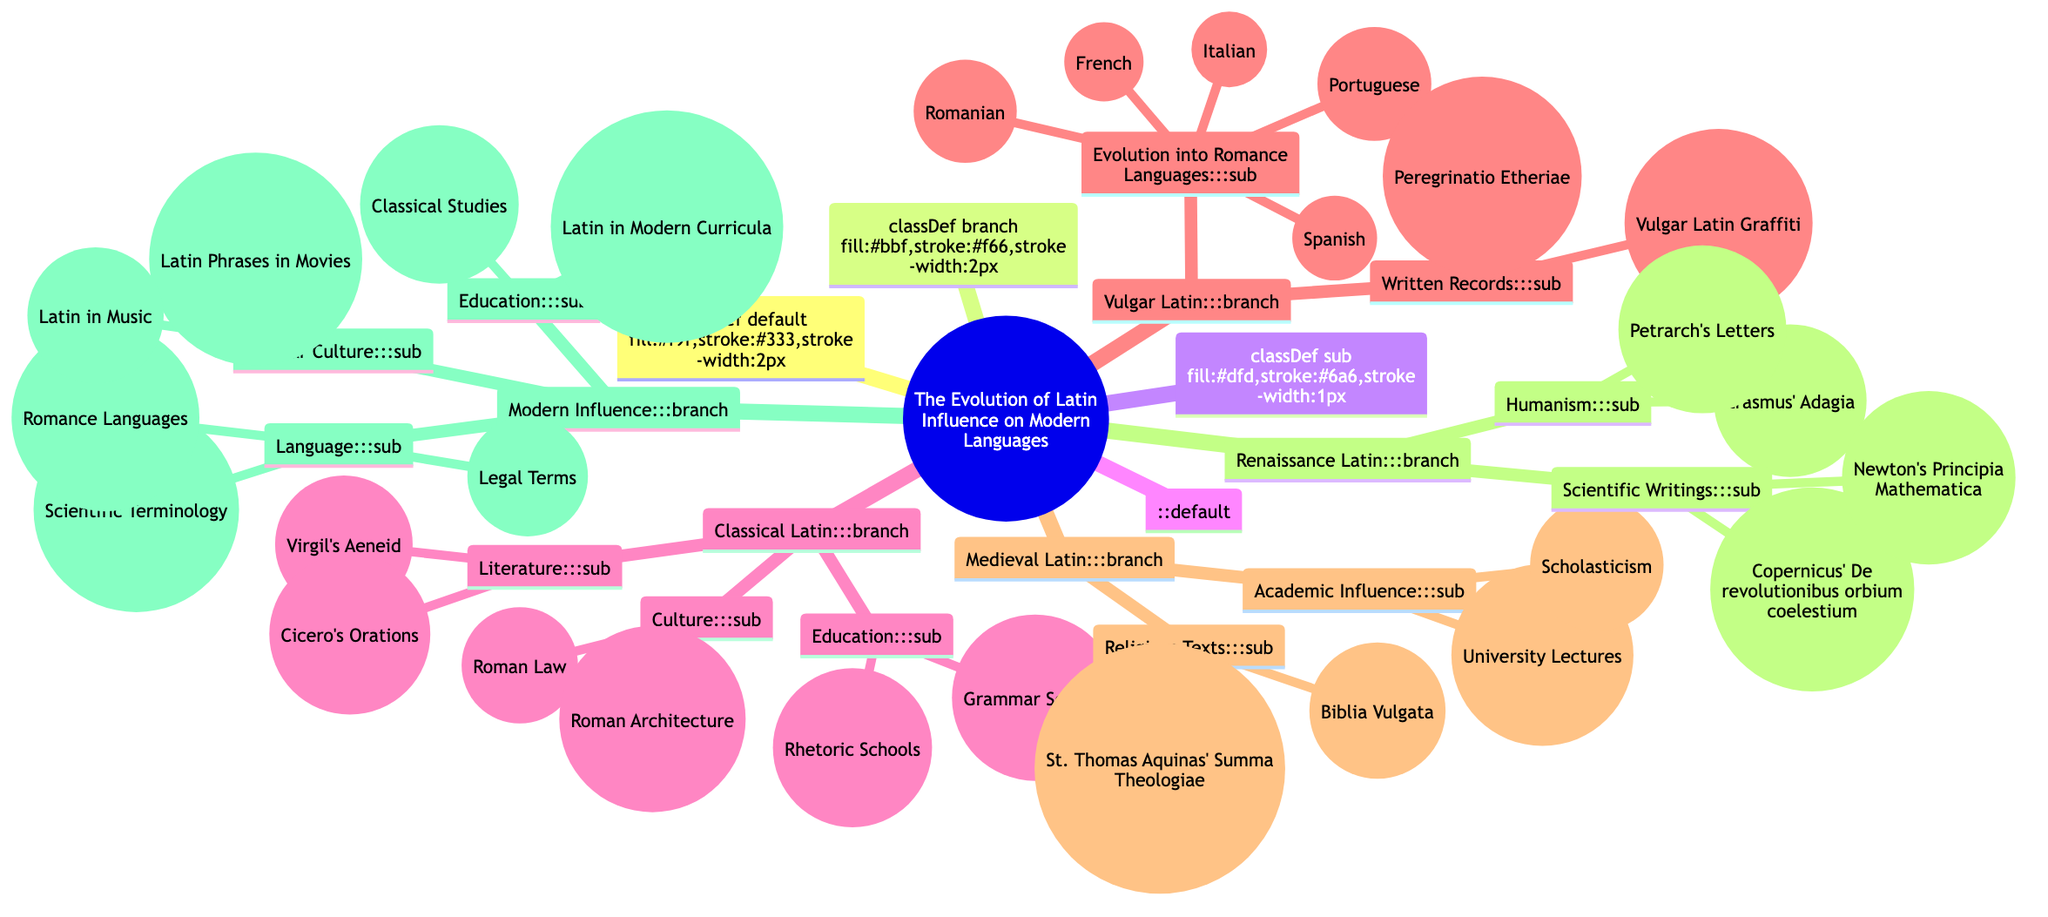What is the central theme of the mind map? The central theme is stated at the root of the mind map, which clearly identifies it as "The Evolution of Latin Influence on Modern Languages."
Answer: The Evolution of Latin Influence on Modern Languages How many main branches are in the mind map? By counting the main branches that extend from the central theme, we can identify five branches: Classical Latin, Vulgar Latin, Medieval Latin, Renaissance Latin, and Modern Influence.
Answer: 5 What literary work is mentioned under Classical Latin? Under the 'Literature' sub-branch of 'Classical Latin', "Virgil's Aeneid" is explicitly listed as an example.
Answer: Virgil's Aeneid Which modern languages evolved from Vulgar Latin? The diagram lists five languages under the 'Evolution into Romance Languages' sub-branch of 'Vulgar Latin', they are French, Italian, Spanish, Portuguese, and Romanian.
Answer: French, Italian, Spanish, Portuguese, Romanian What type of texts are included in Medieval Latin? The 'Religious Texts' sub-branch of 'Medieval Latin' includes examples such as "Biblia Vulgata" and "St. Thomas Aquinas' Summa Theologiae," indicating that the primary focus is on religious literature.
Answer: Religious Texts How does Renaissance Latin influence modern culture? The 'Popular Culture' sub-branch under 'Modern Influence' indicates that Latin has a place in modern media and entertainment, specifically noting examples like "Latin Phrases in Movies" and "Latin in Music."
Answer: Popular Culture What major academic influence does Medieval Latin have? The 'Academic Influence' sub-branch of 'Medieval Latin' includes examples such as "University Lectures" and "Scholasticism", denoting its significant role in medieval scholarship and academia.
Answer: Academic Influence Which Latin works signify the Humanism movement during the Renaissance? Under the 'Humanism' sub-branch of 'Renaissance Latin', "Erasmus' Adagia" and "Petrarch's Letters" are examples pointing to the intellectual movement emphasizing classical texts during the Renaissance.
Answer: Erasmus' Adagia, Petrarch's Letters How does Modern Influence connect to education? The 'Education' sub-branch under 'Modern Influence' specifies "Classical Studies" and "Latin in Modern Curricula," highlighting Latin's continued role in contemporary educational systems.
Answer: Education 